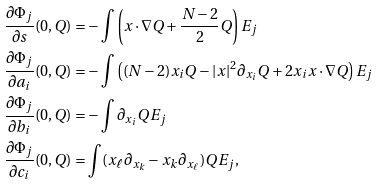<formula> <loc_0><loc_0><loc_500><loc_500>\frac { \partial \Phi _ { j } } { \partial s } ( 0 , Q ) & = - \int \left ( x \cdot \nabla Q + \frac { N - 2 } { 2 } Q \right ) E _ { j } \\ \frac { \partial \Phi _ { j } } { \partial a _ { i } } ( 0 , Q ) & = - \int \left ( ( N - 2 ) x _ { i } Q - | x | ^ { 2 } \partial _ { x _ { i } } Q + 2 x _ { i } x \cdot \nabla Q \right ) E _ { j } \\ \frac { \partial \Phi _ { j } } { \partial b _ { i } } ( 0 , Q ) & = - \int \partial _ { x _ { i } } Q E _ { j } \\ \frac { \partial \Phi _ { j } } { \partial c _ { i } } ( 0 , Q ) & = \int ( x _ { \ell } \partial _ { x _ { k } } - x _ { k } \partial _ { x _ { \ell } } ) Q E _ { j } ,</formula> 